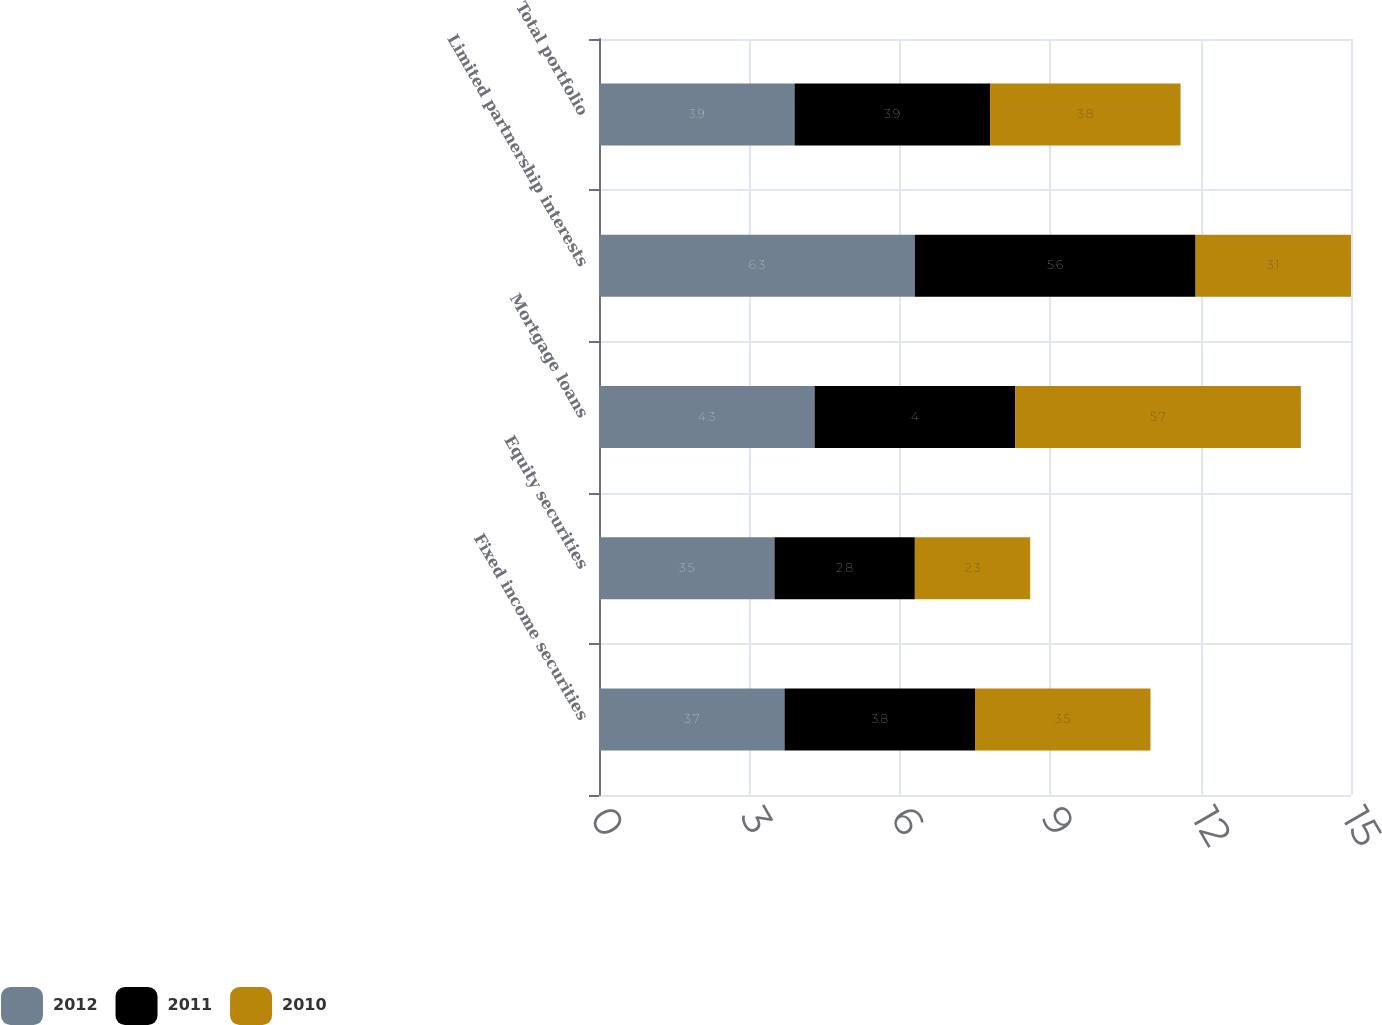<chart> <loc_0><loc_0><loc_500><loc_500><stacked_bar_chart><ecel><fcel>Fixed income securities<fcel>Equity securities<fcel>Mortgage loans<fcel>Limited partnership interests<fcel>Total portfolio<nl><fcel>2012<fcel>3.7<fcel>3.5<fcel>4.3<fcel>6.3<fcel>3.9<nl><fcel>2011<fcel>3.8<fcel>2.8<fcel>4<fcel>5.6<fcel>3.9<nl><fcel>2010<fcel>3.5<fcel>2.3<fcel>5.7<fcel>3.1<fcel>3.8<nl></chart> 